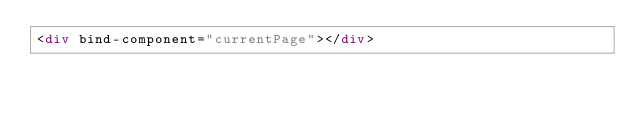<code> <loc_0><loc_0><loc_500><loc_500><_HTML_><div bind-component="currentPage"></div></code> 